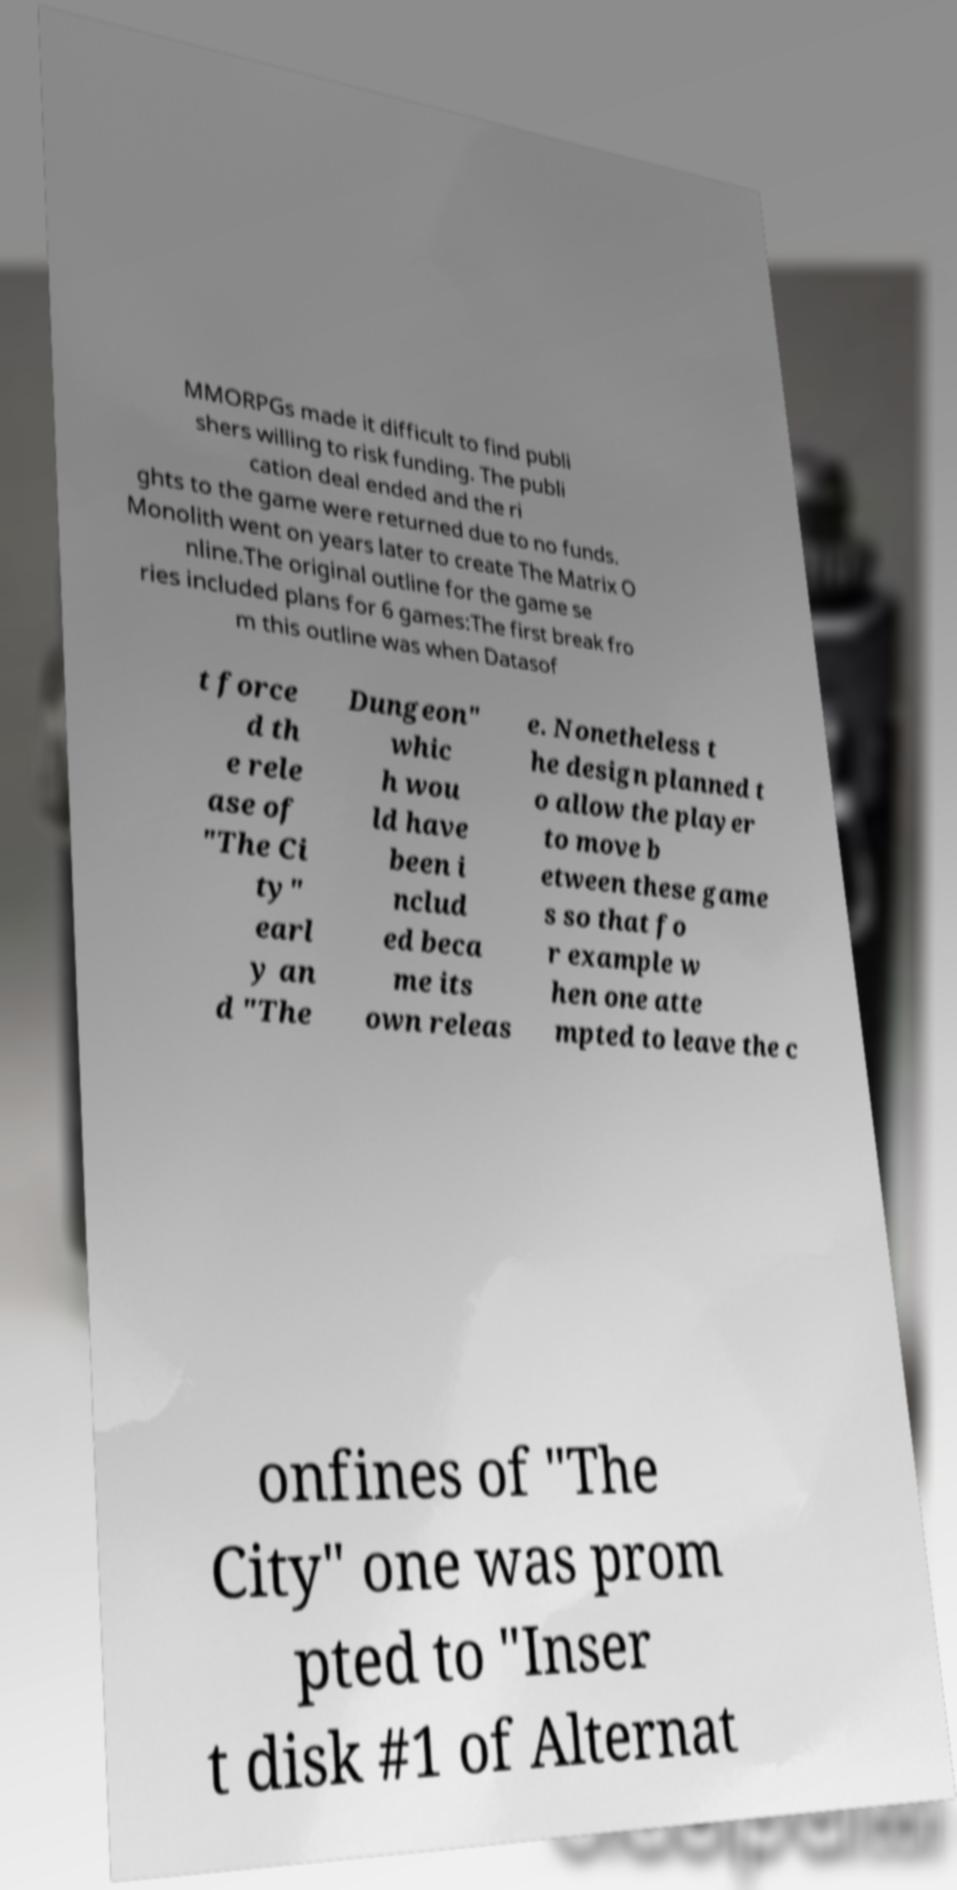There's text embedded in this image that I need extracted. Can you transcribe it verbatim? MMORPGs made it difficult to find publi shers willing to risk funding. The publi cation deal ended and the ri ghts to the game were returned due to no funds. Monolith went on years later to create The Matrix O nline.The original outline for the game se ries included plans for 6 games:The first break fro m this outline was when Datasof t force d th e rele ase of "The Ci ty" earl y an d "The Dungeon" whic h wou ld have been i nclud ed beca me its own releas e. Nonetheless t he design planned t o allow the player to move b etween these game s so that fo r example w hen one atte mpted to leave the c onfines of "The City" one was prom pted to "Inser t disk #1 of Alternat 